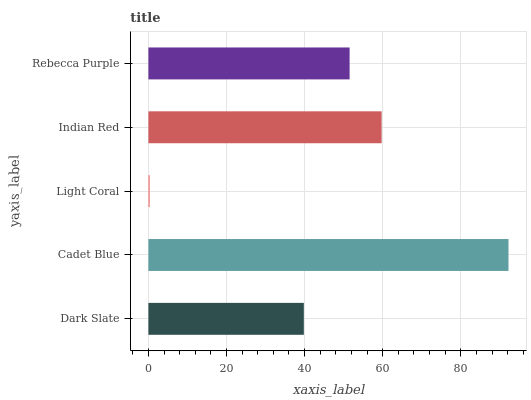Is Light Coral the minimum?
Answer yes or no. Yes. Is Cadet Blue the maximum?
Answer yes or no. Yes. Is Cadet Blue the minimum?
Answer yes or no. No. Is Light Coral the maximum?
Answer yes or no. No. Is Cadet Blue greater than Light Coral?
Answer yes or no. Yes. Is Light Coral less than Cadet Blue?
Answer yes or no. Yes. Is Light Coral greater than Cadet Blue?
Answer yes or no. No. Is Cadet Blue less than Light Coral?
Answer yes or no. No. Is Rebecca Purple the high median?
Answer yes or no. Yes. Is Rebecca Purple the low median?
Answer yes or no. Yes. Is Dark Slate the high median?
Answer yes or no. No. Is Indian Red the low median?
Answer yes or no. No. 